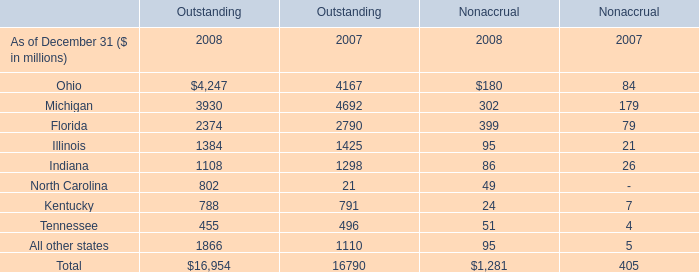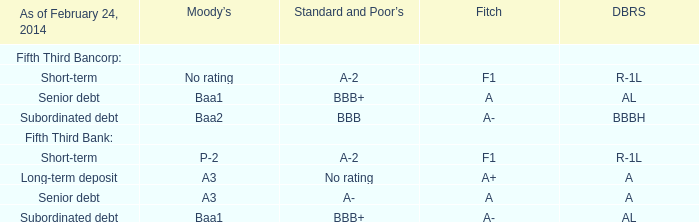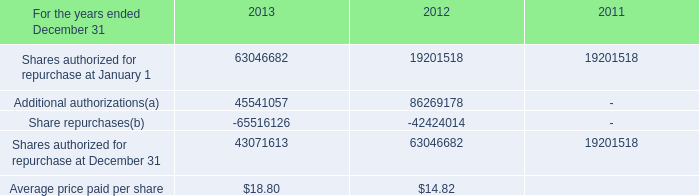what is the total cash outflow spent for shares repurchased during 2013 , in millions? 
Computations: ((18.80 * 43071613) / 1000000)
Answer: 809.74632. 